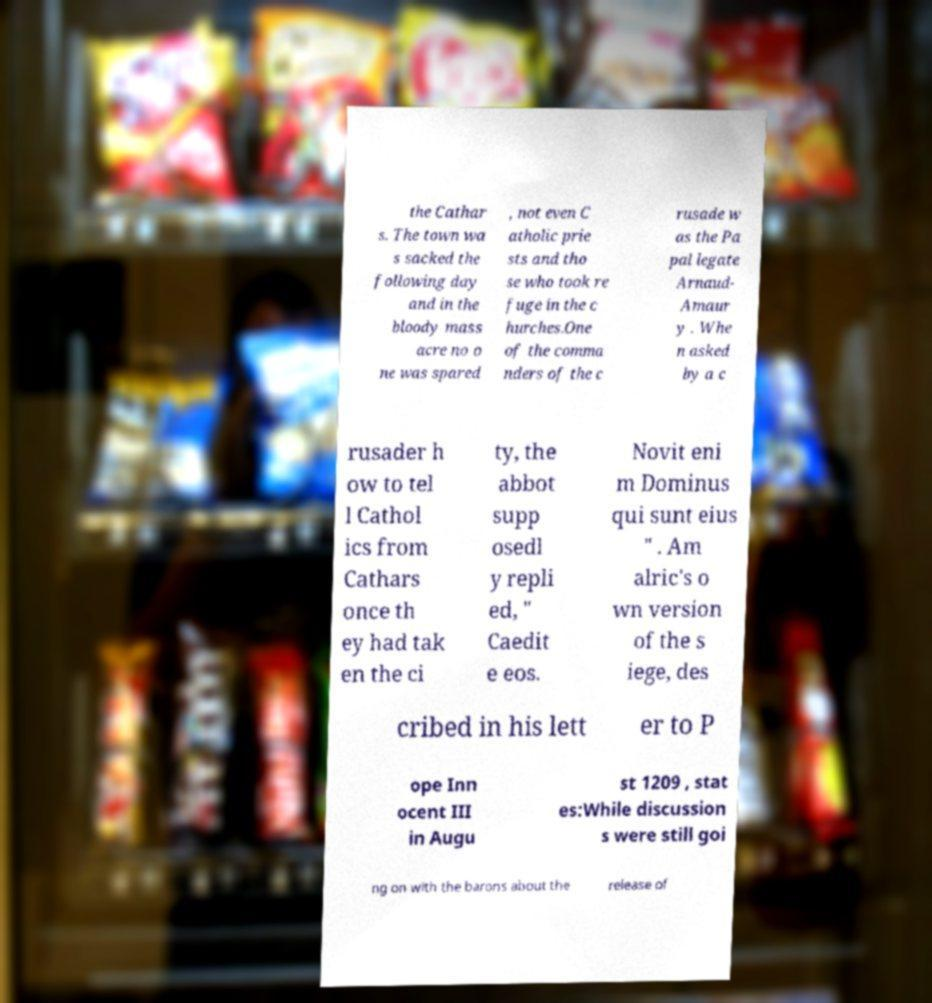Please read and relay the text visible in this image. What does it say? the Cathar s. The town wa s sacked the following day and in the bloody mass acre no o ne was spared , not even C atholic prie sts and tho se who took re fuge in the c hurches.One of the comma nders of the c rusade w as the Pa pal legate Arnaud- Amaur y . Whe n asked by a c rusader h ow to tel l Cathol ics from Cathars once th ey had tak en the ci ty, the abbot supp osedl y repli ed, " Caedit e eos. Novit eni m Dominus qui sunt eius " . Am alric's o wn version of the s iege, des cribed in his lett er to P ope Inn ocent III in Augu st 1209 , stat es:While discussion s were still goi ng on with the barons about the release of 